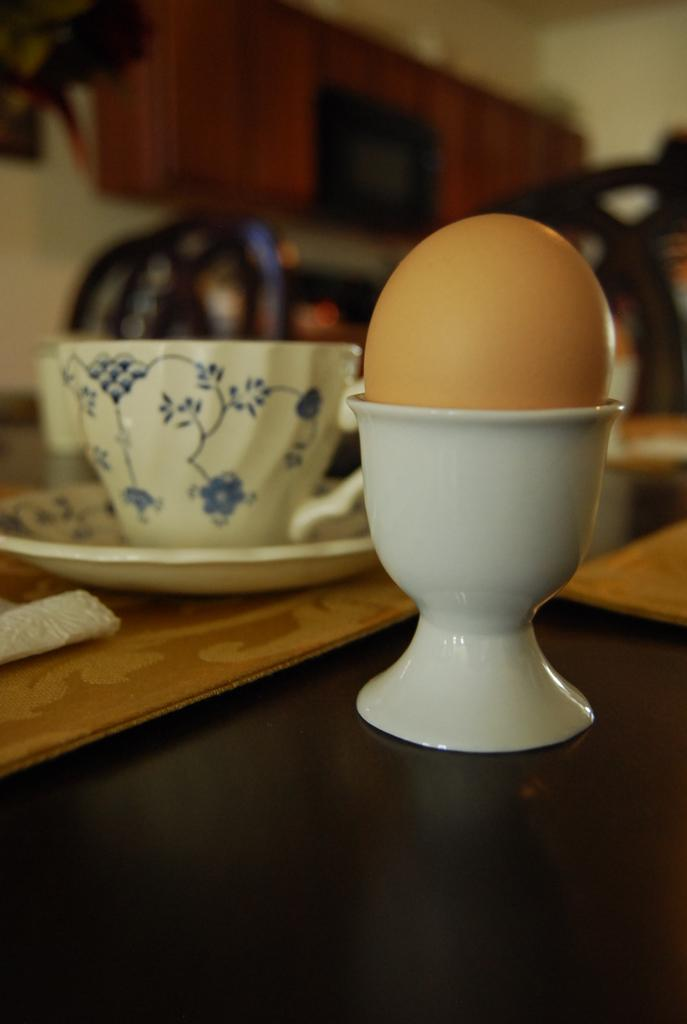What is placed in the plastic bowl in the image? There is an egg in a plastic bowl in the image. What can be seen on the left side of the image? There is a cup in a saucer on the left side of the image. What is the color of the cup and saucer? Both the cup and saucer are white in color. What day of the week is depicted in the image? The image does not depict a specific day of the week; it only shows an egg in a plastic bowl and a white cup and saucer. Can you tell me how many times the egg jumps in the image? The egg does not jump in the image; it is stationary in the plastic bowl. 